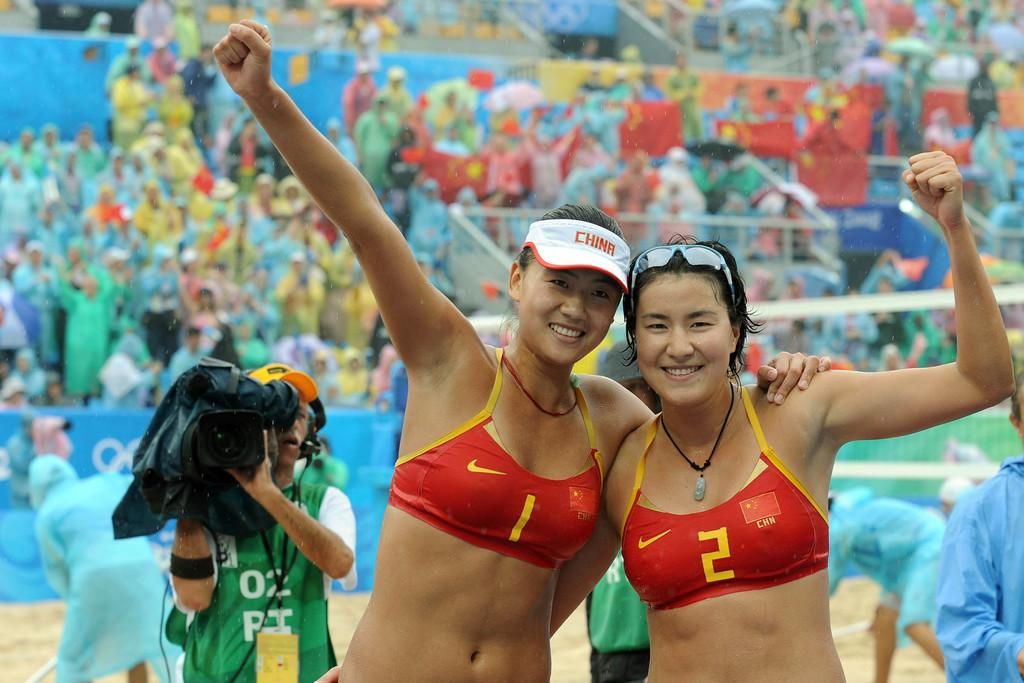How many women are in the image? There are two women in the image. What are the women doing in the image? The women are posing for a photograph. Can you describe the background of the image? There are people in the background of the image. Who is holding the camera in the image? A man is holding a camera in the background. What type of sticks are being used to roast the bean in the image? There are no sticks or beans present in the image; it features two women posing for a photograph with people and a man holding a camera in the background. 